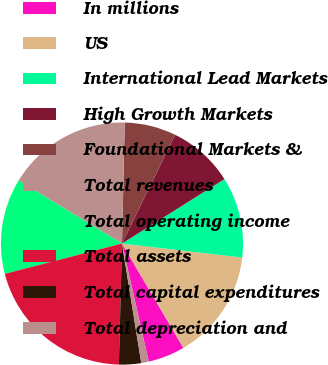Convert chart. <chart><loc_0><loc_0><loc_500><loc_500><pie_chart><fcel>In millions<fcel>US<fcel>International Lead Markets<fcel>High Growth Markets<fcel>Foundational Markets &<fcel>Total revenues<fcel>Total operating income<fcel>Total assets<fcel>Total capital expenditures<fcel>Total depreciation and<nl><fcel>4.92%<fcel>14.69%<fcel>10.78%<fcel>8.83%<fcel>6.87%<fcel>16.65%<fcel>12.74%<fcel>20.56%<fcel>2.96%<fcel>1.0%<nl></chart> 